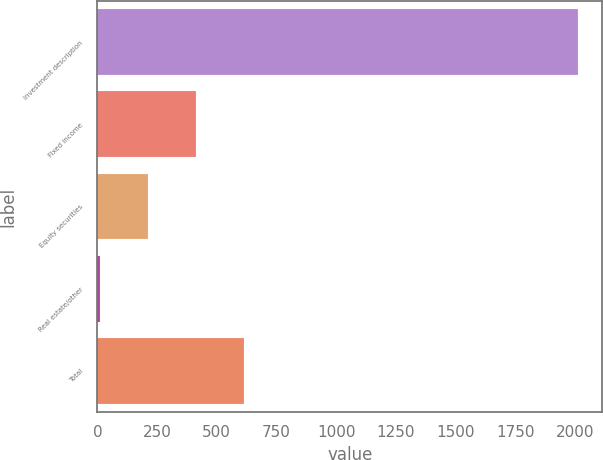Convert chart. <chart><loc_0><loc_0><loc_500><loc_500><bar_chart><fcel>Investment description<fcel>Fixed income<fcel>Equity securities<fcel>Real estate/other<fcel>Total<nl><fcel>2013<fcel>412.28<fcel>212.19<fcel>12.1<fcel>612.37<nl></chart> 